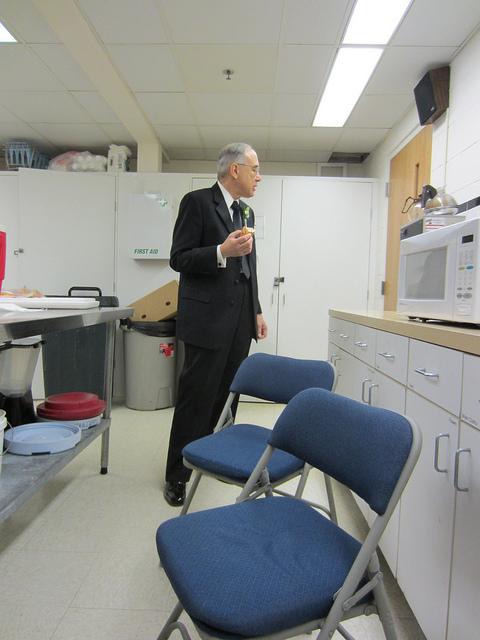What color is the microwave?
Write a very short answer. White. Is there a microwave?
Keep it brief. Yes. How many blue chairs are there?
Give a very brief answer. 2. 